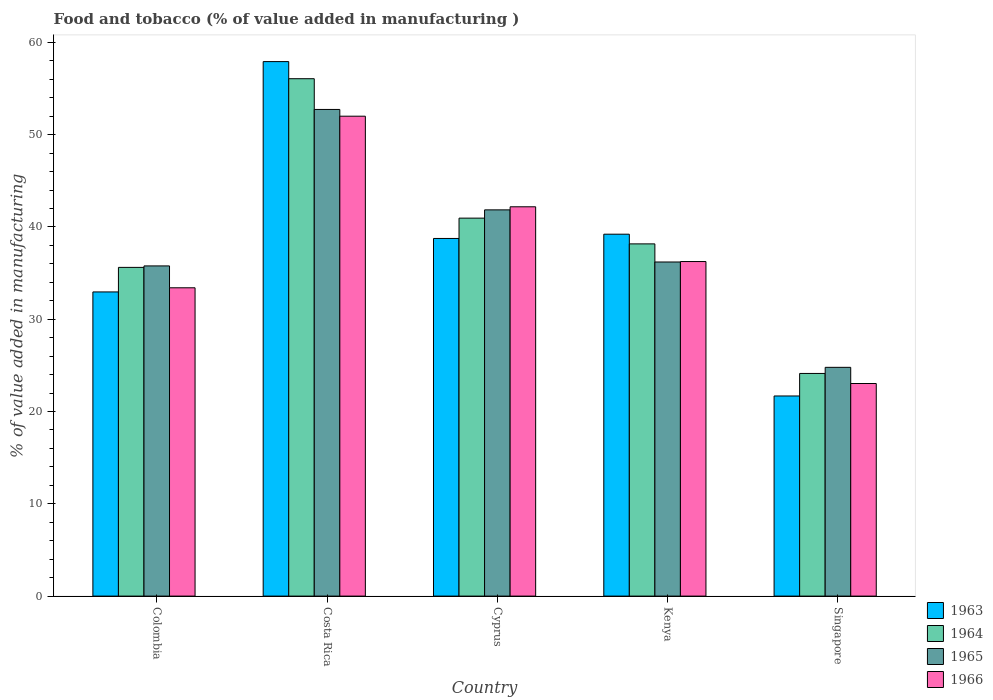Are the number of bars per tick equal to the number of legend labels?
Ensure brevity in your answer.  Yes. What is the label of the 1st group of bars from the left?
Your response must be concise. Colombia. In how many cases, is the number of bars for a given country not equal to the number of legend labels?
Provide a succinct answer. 0. What is the value added in manufacturing food and tobacco in 1964 in Kenya?
Offer a terse response. 38.17. Across all countries, what is the maximum value added in manufacturing food and tobacco in 1966?
Provide a succinct answer. 52. Across all countries, what is the minimum value added in manufacturing food and tobacco in 1965?
Keep it short and to the point. 24.79. In which country was the value added in manufacturing food and tobacco in 1966 maximum?
Provide a short and direct response. Costa Rica. In which country was the value added in manufacturing food and tobacco in 1965 minimum?
Offer a terse response. Singapore. What is the total value added in manufacturing food and tobacco in 1966 in the graph?
Give a very brief answer. 186.89. What is the difference between the value added in manufacturing food and tobacco in 1964 in Colombia and that in Costa Rica?
Provide a short and direct response. -20.45. What is the difference between the value added in manufacturing food and tobacco in 1964 in Kenya and the value added in manufacturing food and tobacco in 1965 in Colombia?
Provide a succinct answer. 2.39. What is the average value added in manufacturing food and tobacco in 1964 per country?
Offer a terse response. 38.99. What is the difference between the value added in manufacturing food and tobacco of/in 1964 and value added in manufacturing food and tobacco of/in 1963 in Kenya?
Your answer should be compact. -1.05. In how many countries, is the value added in manufacturing food and tobacco in 1966 greater than 42 %?
Give a very brief answer. 2. What is the ratio of the value added in manufacturing food and tobacco in 1965 in Cyprus to that in Singapore?
Provide a succinct answer. 1.69. Is the difference between the value added in manufacturing food and tobacco in 1964 in Colombia and Costa Rica greater than the difference between the value added in manufacturing food and tobacco in 1963 in Colombia and Costa Rica?
Provide a short and direct response. Yes. What is the difference between the highest and the second highest value added in manufacturing food and tobacco in 1966?
Keep it short and to the point. -9.82. What is the difference between the highest and the lowest value added in manufacturing food and tobacco in 1964?
Provide a short and direct response. 31.94. Is the sum of the value added in manufacturing food and tobacco in 1964 in Cyprus and Kenya greater than the maximum value added in manufacturing food and tobacco in 1963 across all countries?
Your response must be concise. Yes. What does the 4th bar from the left in Costa Rica represents?
Offer a terse response. 1966. What does the 1st bar from the right in Kenya represents?
Keep it short and to the point. 1966. Is it the case that in every country, the sum of the value added in manufacturing food and tobacco in 1965 and value added in manufacturing food and tobacco in 1964 is greater than the value added in manufacturing food and tobacco in 1966?
Offer a very short reply. Yes. How many countries are there in the graph?
Your answer should be very brief. 5. What is the difference between two consecutive major ticks on the Y-axis?
Keep it short and to the point. 10. Are the values on the major ticks of Y-axis written in scientific E-notation?
Offer a terse response. No. Does the graph contain any zero values?
Make the answer very short. No. What is the title of the graph?
Make the answer very short. Food and tobacco (% of value added in manufacturing ). Does "1960" appear as one of the legend labels in the graph?
Provide a succinct answer. No. What is the label or title of the X-axis?
Ensure brevity in your answer.  Country. What is the label or title of the Y-axis?
Ensure brevity in your answer.  % of value added in manufacturing. What is the % of value added in manufacturing of 1963 in Colombia?
Your answer should be very brief. 32.96. What is the % of value added in manufacturing of 1964 in Colombia?
Provide a succinct answer. 35.62. What is the % of value added in manufacturing of 1965 in Colombia?
Your answer should be compact. 35.78. What is the % of value added in manufacturing in 1966 in Colombia?
Ensure brevity in your answer.  33.41. What is the % of value added in manufacturing of 1963 in Costa Rica?
Keep it short and to the point. 57.92. What is the % of value added in manufacturing of 1964 in Costa Rica?
Keep it short and to the point. 56.07. What is the % of value added in manufacturing in 1965 in Costa Rica?
Keep it short and to the point. 52.73. What is the % of value added in manufacturing of 1966 in Costa Rica?
Provide a succinct answer. 52. What is the % of value added in manufacturing in 1963 in Cyprus?
Make the answer very short. 38.75. What is the % of value added in manufacturing in 1964 in Cyprus?
Ensure brevity in your answer.  40.96. What is the % of value added in manufacturing in 1965 in Cyprus?
Offer a terse response. 41.85. What is the % of value added in manufacturing of 1966 in Cyprus?
Provide a short and direct response. 42.19. What is the % of value added in manufacturing of 1963 in Kenya?
Your response must be concise. 39.22. What is the % of value added in manufacturing in 1964 in Kenya?
Give a very brief answer. 38.17. What is the % of value added in manufacturing in 1965 in Kenya?
Provide a short and direct response. 36.2. What is the % of value added in manufacturing of 1966 in Kenya?
Provide a short and direct response. 36.25. What is the % of value added in manufacturing of 1963 in Singapore?
Keep it short and to the point. 21.69. What is the % of value added in manufacturing of 1964 in Singapore?
Keep it short and to the point. 24.13. What is the % of value added in manufacturing in 1965 in Singapore?
Your answer should be compact. 24.79. What is the % of value added in manufacturing in 1966 in Singapore?
Your answer should be very brief. 23.04. Across all countries, what is the maximum % of value added in manufacturing in 1963?
Offer a very short reply. 57.92. Across all countries, what is the maximum % of value added in manufacturing in 1964?
Provide a succinct answer. 56.07. Across all countries, what is the maximum % of value added in manufacturing of 1965?
Your answer should be very brief. 52.73. Across all countries, what is the maximum % of value added in manufacturing in 1966?
Offer a very short reply. 52. Across all countries, what is the minimum % of value added in manufacturing of 1963?
Your answer should be compact. 21.69. Across all countries, what is the minimum % of value added in manufacturing in 1964?
Offer a terse response. 24.13. Across all countries, what is the minimum % of value added in manufacturing of 1965?
Offer a terse response. 24.79. Across all countries, what is the minimum % of value added in manufacturing of 1966?
Give a very brief answer. 23.04. What is the total % of value added in manufacturing in 1963 in the graph?
Provide a short and direct response. 190.54. What is the total % of value added in manufacturing in 1964 in the graph?
Ensure brevity in your answer.  194.94. What is the total % of value added in manufacturing in 1965 in the graph?
Offer a terse response. 191.36. What is the total % of value added in manufacturing in 1966 in the graph?
Ensure brevity in your answer.  186.89. What is the difference between the % of value added in manufacturing in 1963 in Colombia and that in Costa Rica?
Keep it short and to the point. -24.96. What is the difference between the % of value added in manufacturing of 1964 in Colombia and that in Costa Rica?
Give a very brief answer. -20.45. What is the difference between the % of value added in manufacturing of 1965 in Colombia and that in Costa Rica?
Provide a short and direct response. -16.95. What is the difference between the % of value added in manufacturing in 1966 in Colombia and that in Costa Rica?
Offer a very short reply. -18.59. What is the difference between the % of value added in manufacturing in 1963 in Colombia and that in Cyprus?
Offer a very short reply. -5.79. What is the difference between the % of value added in manufacturing in 1964 in Colombia and that in Cyprus?
Provide a succinct answer. -5.34. What is the difference between the % of value added in manufacturing in 1965 in Colombia and that in Cyprus?
Offer a terse response. -6.07. What is the difference between the % of value added in manufacturing of 1966 in Colombia and that in Cyprus?
Your answer should be very brief. -8.78. What is the difference between the % of value added in manufacturing of 1963 in Colombia and that in Kenya?
Ensure brevity in your answer.  -6.26. What is the difference between the % of value added in manufacturing of 1964 in Colombia and that in Kenya?
Provide a short and direct response. -2.55. What is the difference between the % of value added in manufacturing of 1965 in Colombia and that in Kenya?
Your answer should be compact. -0.42. What is the difference between the % of value added in manufacturing of 1966 in Colombia and that in Kenya?
Your response must be concise. -2.84. What is the difference between the % of value added in manufacturing in 1963 in Colombia and that in Singapore?
Offer a terse response. 11.27. What is the difference between the % of value added in manufacturing in 1964 in Colombia and that in Singapore?
Your answer should be compact. 11.49. What is the difference between the % of value added in manufacturing in 1965 in Colombia and that in Singapore?
Give a very brief answer. 10.99. What is the difference between the % of value added in manufacturing of 1966 in Colombia and that in Singapore?
Offer a very short reply. 10.37. What is the difference between the % of value added in manufacturing in 1963 in Costa Rica and that in Cyprus?
Make the answer very short. 19.17. What is the difference between the % of value added in manufacturing of 1964 in Costa Rica and that in Cyprus?
Make the answer very short. 15.11. What is the difference between the % of value added in manufacturing in 1965 in Costa Rica and that in Cyprus?
Your answer should be compact. 10.88. What is the difference between the % of value added in manufacturing in 1966 in Costa Rica and that in Cyprus?
Ensure brevity in your answer.  9.82. What is the difference between the % of value added in manufacturing of 1963 in Costa Rica and that in Kenya?
Offer a very short reply. 18.7. What is the difference between the % of value added in manufacturing of 1964 in Costa Rica and that in Kenya?
Make the answer very short. 17.9. What is the difference between the % of value added in manufacturing of 1965 in Costa Rica and that in Kenya?
Provide a succinct answer. 16.53. What is the difference between the % of value added in manufacturing of 1966 in Costa Rica and that in Kenya?
Give a very brief answer. 15.75. What is the difference between the % of value added in manufacturing of 1963 in Costa Rica and that in Singapore?
Offer a terse response. 36.23. What is the difference between the % of value added in manufacturing of 1964 in Costa Rica and that in Singapore?
Your response must be concise. 31.94. What is the difference between the % of value added in manufacturing of 1965 in Costa Rica and that in Singapore?
Keep it short and to the point. 27.94. What is the difference between the % of value added in manufacturing of 1966 in Costa Rica and that in Singapore?
Provide a short and direct response. 28.97. What is the difference between the % of value added in manufacturing of 1963 in Cyprus and that in Kenya?
Make the answer very short. -0.46. What is the difference between the % of value added in manufacturing in 1964 in Cyprus and that in Kenya?
Your response must be concise. 2.79. What is the difference between the % of value added in manufacturing of 1965 in Cyprus and that in Kenya?
Offer a terse response. 5.65. What is the difference between the % of value added in manufacturing in 1966 in Cyprus and that in Kenya?
Provide a succinct answer. 5.93. What is the difference between the % of value added in manufacturing in 1963 in Cyprus and that in Singapore?
Provide a succinct answer. 17.07. What is the difference between the % of value added in manufacturing of 1964 in Cyprus and that in Singapore?
Give a very brief answer. 16.83. What is the difference between the % of value added in manufacturing in 1965 in Cyprus and that in Singapore?
Make the answer very short. 17.06. What is the difference between the % of value added in manufacturing of 1966 in Cyprus and that in Singapore?
Keep it short and to the point. 19.15. What is the difference between the % of value added in manufacturing in 1963 in Kenya and that in Singapore?
Make the answer very short. 17.53. What is the difference between the % of value added in manufacturing in 1964 in Kenya and that in Singapore?
Keep it short and to the point. 14.04. What is the difference between the % of value added in manufacturing in 1965 in Kenya and that in Singapore?
Make the answer very short. 11.41. What is the difference between the % of value added in manufacturing in 1966 in Kenya and that in Singapore?
Make the answer very short. 13.22. What is the difference between the % of value added in manufacturing of 1963 in Colombia and the % of value added in manufacturing of 1964 in Costa Rica?
Provide a succinct answer. -23.11. What is the difference between the % of value added in manufacturing of 1963 in Colombia and the % of value added in manufacturing of 1965 in Costa Rica?
Your answer should be compact. -19.77. What is the difference between the % of value added in manufacturing of 1963 in Colombia and the % of value added in manufacturing of 1966 in Costa Rica?
Offer a very short reply. -19.04. What is the difference between the % of value added in manufacturing of 1964 in Colombia and the % of value added in manufacturing of 1965 in Costa Rica?
Offer a very short reply. -17.11. What is the difference between the % of value added in manufacturing in 1964 in Colombia and the % of value added in manufacturing in 1966 in Costa Rica?
Keep it short and to the point. -16.38. What is the difference between the % of value added in manufacturing in 1965 in Colombia and the % of value added in manufacturing in 1966 in Costa Rica?
Make the answer very short. -16.22. What is the difference between the % of value added in manufacturing in 1963 in Colombia and the % of value added in manufacturing in 1964 in Cyprus?
Ensure brevity in your answer.  -8. What is the difference between the % of value added in manufacturing of 1963 in Colombia and the % of value added in manufacturing of 1965 in Cyprus?
Your answer should be very brief. -8.89. What is the difference between the % of value added in manufacturing of 1963 in Colombia and the % of value added in manufacturing of 1966 in Cyprus?
Offer a terse response. -9.23. What is the difference between the % of value added in manufacturing of 1964 in Colombia and the % of value added in manufacturing of 1965 in Cyprus?
Offer a terse response. -6.23. What is the difference between the % of value added in manufacturing of 1964 in Colombia and the % of value added in manufacturing of 1966 in Cyprus?
Offer a terse response. -6.57. What is the difference between the % of value added in manufacturing in 1965 in Colombia and the % of value added in manufacturing in 1966 in Cyprus?
Your response must be concise. -6.41. What is the difference between the % of value added in manufacturing in 1963 in Colombia and the % of value added in manufacturing in 1964 in Kenya?
Give a very brief answer. -5.21. What is the difference between the % of value added in manufacturing in 1963 in Colombia and the % of value added in manufacturing in 1965 in Kenya?
Make the answer very short. -3.24. What is the difference between the % of value added in manufacturing of 1963 in Colombia and the % of value added in manufacturing of 1966 in Kenya?
Ensure brevity in your answer.  -3.29. What is the difference between the % of value added in manufacturing of 1964 in Colombia and the % of value added in manufacturing of 1965 in Kenya?
Give a very brief answer. -0.58. What is the difference between the % of value added in manufacturing in 1964 in Colombia and the % of value added in manufacturing in 1966 in Kenya?
Provide a short and direct response. -0.63. What is the difference between the % of value added in manufacturing in 1965 in Colombia and the % of value added in manufacturing in 1966 in Kenya?
Provide a succinct answer. -0.47. What is the difference between the % of value added in manufacturing in 1963 in Colombia and the % of value added in manufacturing in 1964 in Singapore?
Your answer should be compact. 8.83. What is the difference between the % of value added in manufacturing in 1963 in Colombia and the % of value added in manufacturing in 1965 in Singapore?
Your answer should be compact. 8.17. What is the difference between the % of value added in manufacturing of 1963 in Colombia and the % of value added in manufacturing of 1966 in Singapore?
Your answer should be compact. 9.92. What is the difference between the % of value added in manufacturing of 1964 in Colombia and the % of value added in manufacturing of 1965 in Singapore?
Keep it short and to the point. 10.83. What is the difference between the % of value added in manufacturing in 1964 in Colombia and the % of value added in manufacturing in 1966 in Singapore?
Offer a terse response. 12.58. What is the difference between the % of value added in manufacturing of 1965 in Colombia and the % of value added in manufacturing of 1966 in Singapore?
Offer a terse response. 12.74. What is the difference between the % of value added in manufacturing in 1963 in Costa Rica and the % of value added in manufacturing in 1964 in Cyprus?
Ensure brevity in your answer.  16.96. What is the difference between the % of value added in manufacturing in 1963 in Costa Rica and the % of value added in manufacturing in 1965 in Cyprus?
Your answer should be compact. 16.07. What is the difference between the % of value added in manufacturing in 1963 in Costa Rica and the % of value added in manufacturing in 1966 in Cyprus?
Offer a very short reply. 15.73. What is the difference between the % of value added in manufacturing in 1964 in Costa Rica and the % of value added in manufacturing in 1965 in Cyprus?
Provide a succinct answer. 14.21. What is the difference between the % of value added in manufacturing in 1964 in Costa Rica and the % of value added in manufacturing in 1966 in Cyprus?
Offer a terse response. 13.88. What is the difference between the % of value added in manufacturing of 1965 in Costa Rica and the % of value added in manufacturing of 1966 in Cyprus?
Offer a very short reply. 10.55. What is the difference between the % of value added in manufacturing in 1963 in Costa Rica and the % of value added in manufacturing in 1964 in Kenya?
Your answer should be very brief. 19.75. What is the difference between the % of value added in manufacturing in 1963 in Costa Rica and the % of value added in manufacturing in 1965 in Kenya?
Your answer should be very brief. 21.72. What is the difference between the % of value added in manufacturing of 1963 in Costa Rica and the % of value added in manufacturing of 1966 in Kenya?
Offer a very short reply. 21.67. What is the difference between the % of value added in manufacturing of 1964 in Costa Rica and the % of value added in manufacturing of 1965 in Kenya?
Your response must be concise. 19.86. What is the difference between the % of value added in manufacturing in 1964 in Costa Rica and the % of value added in manufacturing in 1966 in Kenya?
Keep it short and to the point. 19.81. What is the difference between the % of value added in manufacturing in 1965 in Costa Rica and the % of value added in manufacturing in 1966 in Kenya?
Make the answer very short. 16.48. What is the difference between the % of value added in manufacturing in 1963 in Costa Rica and the % of value added in manufacturing in 1964 in Singapore?
Offer a terse response. 33.79. What is the difference between the % of value added in manufacturing of 1963 in Costa Rica and the % of value added in manufacturing of 1965 in Singapore?
Ensure brevity in your answer.  33.13. What is the difference between the % of value added in manufacturing in 1963 in Costa Rica and the % of value added in manufacturing in 1966 in Singapore?
Offer a terse response. 34.88. What is the difference between the % of value added in manufacturing of 1964 in Costa Rica and the % of value added in manufacturing of 1965 in Singapore?
Offer a terse response. 31.28. What is the difference between the % of value added in manufacturing in 1964 in Costa Rica and the % of value added in manufacturing in 1966 in Singapore?
Provide a succinct answer. 33.03. What is the difference between the % of value added in manufacturing in 1965 in Costa Rica and the % of value added in manufacturing in 1966 in Singapore?
Give a very brief answer. 29.7. What is the difference between the % of value added in manufacturing in 1963 in Cyprus and the % of value added in manufacturing in 1964 in Kenya?
Give a very brief answer. 0.59. What is the difference between the % of value added in manufacturing of 1963 in Cyprus and the % of value added in manufacturing of 1965 in Kenya?
Give a very brief answer. 2.55. What is the difference between the % of value added in manufacturing in 1963 in Cyprus and the % of value added in manufacturing in 1966 in Kenya?
Ensure brevity in your answer.  2.5. What is the difference between the % of value added in manufacturing of 1964 in Cyprus and the % of value added in manufacturing of 1965 in Kenya?
Make the answer very short. 4.75. What is the difference between the % of value added in manufacturing in 1964 in Cyprus and the % of value added in manufacturing in 1966 in Kenya?
Your response must be concise. 4.7. What is the difference between the % of value added in manufacturing of 1965 in Cyprus and the % of value added in manufacturing of 1966 in Kenya?
Offer a very short reply. 5.6. What is the difference between the % of value added in manufacturing of 1963 in Cyprus and the % of value added in manufacturing of 1964 in Singapore?
Offer a very short reply. 14.63. What is the difference between the % of value added in manufacturing of 1963 in Cyprus and the % of value added in manufacturing of 1965 in Singapore?
Your answer should be compact. 13.96. What is the difference between the % of value added in manufacturing of 1963 in Cyprus and the % of value added in manufacturing of 1966 in Singapore?
Your response must be concise. 15.72. What is the difference between the % of value added in manufacturing in 1964 in Cyprus and the % of value added in manufacturing in 1965 in Singapore?
Your response must be concise. 16.17. What is the difference between the % of value added in manufacturing of 1964 in Cyprus and the % of value added in manufacturing of 1966 in Singapore?
Provide a succinct answer. 17.92. What is the difference between the % of value added in manufacturing in 1965 in Cyprus and the % of value added in manufacturing in 1966 in Singapore?
Your response must be concise. 18.82. What is the difference between the % of value added in manufacturing of 1963 in Kenya and the % of value added in manufacturing of 1964 in Singapore?
Your answer should be compact. 15.09. What is the difference between the % of value added in manufacturing of 1963 in Kenya and the % of value added in manufacturing of 1965 in Singapore?
Your answer should be compact. 14.43. What is the difference between the % of value added in manufacturing of 1963 in Kenya and the % of value added in manufacturing of 1966 in Singapore?
Your answer should be compact. 16.18. What is the difference between the % of value added in manufacturing in 1964 in Kenya and the % of value added in manufacturing in 1965 in Singapore?
Provide a succinct answer. 13.38. What is the difference between the % of value added in manufacturing of 1964 in Kenya and the % of value added in manufacturing of 1966 in Singapore?
Your answer should be compact. 15.13. What is the difference between the % of value added in manufacturing of 1965 in Kenya and the % of value added in manufacturing of 1966 in Singapore?
Provide a short and direct response. 13.17. What is the average % of value added in manufacturing in 1963 per country?
Give a very brief answer. 38.11. What is the average % of value added in manufacturing in 1964 per country?
Provide a short and direct response. 38.99. What is the average % of value added in manufacturing in 1965 per country?
Your answer should be compact. 38.27. What is the average % of value added in manufacturing in 1966 per country?
Provide a succinct answer. 37.38. What is the difference between the % of value added in manufacturing of 1963 and % of value added in manufacturing of 1964 in Colombia?
Give a very brief answer. -2.66. What is the difference between the % of value added in manufacturing in 1963 and % of value added in manufacturing in 1965 in Colombia?
Make the answer very short. -2.82. What is the difference between the % of value added in manufacturing in 1963 and % of value added in manufacturing in 1966 in Colombia?
Offer a very short reply. -0.45. What is the difference between the % of value added in manufacturing in 1964 and % of value added in manufacturing in 1965 in Colombia?
Provide a short and direct response. -0.16. What is the difference between the % of value added in manufacturing in 1964 and % of value added in manufacturing in 1966 in Colombia?
Make the answer very short. 2.21. What is the difference between the % of value added in manufacturing of 1965 and % of value added in manufacturing of 1966 in Colombia?
Give a very brief answer. 2.37. What is the difference between the % of value added in manufacturing in 1963 and % of value added in manufacturing in 1964 in Costa Rica?
Your answer should be very brief. 1.85. What is the difference between the % of value added in manufacturing of 1963 and % of value added in manufacturing of 1965 in Costa Rica?
Offer a terse response. 5.19. What is the difference between the % of value added in manufacturing in 1963 and % of value added in manufacturing in 1966 in Costa Rica?
Make the answer very short. 5.92. What is the difference between the % of value added in manufacturing in 1964 and % of value added in manufacturing in 1965 in Costa Rica?
Offer a terse response. 3.33. What is the difference between the % of value added in manufacturing of 1964 and % of value added in manufacturing of 1966 in Costa Rica?
Ensure brevity in your answer.  4.06. What is the difference between the % of value added in manufacturing of 1965 and % of value added in manufacturing of 1966 in Costa Rica?
Your answer should be compact. 0.73. What is the difference between the % of value added in manufacturing of 1963 and % of value added in manufacturing of 1964 in Cyprus?
Give a very brief answer. -2.2. What is the difference between the % of value added in manufacturing of 1963 and % of value added in manufacturing of 1965 in Cyprus?
Give a very brief answer. -3.1. What is the difference between the % of value added in manufacturing of 1963 and % of value added in manufacturing of 1966 in Cyprus?
Offer a terse response. -3.43. What is the difference between the % of value added in manufacturing of 1964 and % of value added in manufacturing of 1965 in Cyprus?
Provide a succinct answer. -0.9. What is the difference between the % of value added in manufacturing in 1964 and % of value added in manufacturing in 1966 in Cyprus?
Keep it short and to the point. -1.23. What is the difference between the % of value added in manufacturing of 1965 and % of value added in manufacturing of 1966 in Cyprus?
Your answer should be compact. -0.33. What is the difference between the % of value added in manufacturing in 1963 and % of value added in manufacturing in 1964 in Kenya?
Offer a very short reply. 1.05. What is the difference between the % of value added in manufacturing in 1963 and % of value added in manufacturing in 1965 in Kenya?
Make the answer very short. 3.01. What is the difference between the % of value added in manufacturing of 1963 and % of value added in manufacturing of 1966 in Kenya?
Provide a succinct answer. 2.96. What is the difference between the % of value added in manufacturing of 1964 and % of value added in manufacturing of 1965 in Kenya?
Your response must be concise. 1.96. What is the difference between the % of value added in manufacturing of 1964 and % of value added in manufacturing of 1966 in Kenya?
Make the answer very short. 1.91. What is the difference between the % of value added in manufacturing in 1965 and % of value added in manufacturing in 1966 in Kenya?
Provide a succinct answer. -0.05. What is the difference between the % of value added in manufacturing of 1963 and % of value added in manufacturing of 1964 in Singapore?
Your answer should be compact. -2.44. What is the difference between the % of value added in manufacturing of 1963 and % of value added in manufacturing of 1965 in Singapore?
Offer a terse response. -3.1. What is the difference between the % of value added in manufacturing of 1963 and % of value added in manufacturing of 1966 in Singapore?
Offer a very short reply. -1.35. What is the difference between the % of value added in manufacturing in 1964 and % of value added in manufacturing in 1965 in Singapore?
Give a very brief answer. -0.66. What is the difference between the % of value added in manufacturing of 1964 and % of value added in manufacturing of 1966 in Singapore?
Offer a terse response. 1.09. What is the difference between the % of value added in manufacturing of 1965 and % of value added in manufacturing of 1966 in Singapore?
Offer a very short reply. 1.75. What is the ratio of the % of value added in manufacturing in 1963 in Colombia to that in Costa Rica?
Provide a succinct answer. 0.57. What is the ratio of the % of value added in manufacturing in 1964 in Colombia to that in Costa Rica?
Your answer should be compact. 0.64. What is the ratio of the % of value added in manufacturing of 1965 in Colombia to that in Costa Rica?
Provide a succinct answer. 0.68. What is the ratio of the % of value added in manufacturing of 1966 in Colombia to that in Costa Rica?
Ensure brevity in your answer.  0.64. What is the ratio of the % of value added in manufacturing in 1963 in Colombia to that in Cyprus?
Your answer should be very brief. 0.85. What is the ratio of the % of value added in manufacturing in 1964 in Colombia to that in Cyprus?
Your response must be concise. 0.87. What is the ratio of the % of value added in manufacturing of 1965 in Colombia to that in Cyprus?
Your answer should be very brief. 0.85. What is the ratio of the % of value added in manufacturing of 1966 in Colombia to that in Cyprus?
Your response must be concise. 0.79. What is the ratio of the % of value added in manufacturing of 1963 in Colombia to that in Kenya?
Provide a short and direct response. 0.84. What is the ratio of the % of value added in manufacturing of 1964 in Colombia to that in Kenya?
Provide a succinct answer. 0.93. What is the ratio of the % of value added in manufacturing in 1965 in Colombia to that in Kenya?
Keep it short and to the point. 0.99. What is the ratio of the % of value added in manufacturing of 1966 in Colombia to that in Kenya?
Your answer should be very brief. 0.92. What is the ratio of the % of value added in manufacturing of 1963 in Colombia to that in Singapore?
Provide a succinct answer. 1.52. What is the ratio of the % of value added in manufacturing of 1964 in Colombia to that in Singapore?
Give a very brief answer. 1.48. What is the ratio of the % of value added in manufacturing of 1965 in Colombia to that in Singapore?
Provide a succinct answer. 1.44. What is the ratio of the % of value added in manufacturing in 1966 in Colombia to that in Singapore?
Give a very brief answer. 1.45. What is the ratio of the % of value added in manufacturing of 1963 in Costa Rica to that in Cyprus?
Give a very brief answer. 1.49. What is the ratio of the % of value added in manufacturing in 1964 in Costa Rica to that in Cyprus?
Your answer should be compact. 1.37. What is the ratio of the % of value added in manufacturing in 1965 in Costa Rica to that in Cyprus?
Offer a terse response. 1.26. What is the ratio of the % of value added in manufacturing in 1966 in Costa Rica to that in Cyprus?
Provide a succinct answer. 1.23. What is the ratio of the % of value added in manufacturing of 1963 in Costa Rica to that in Kenya?
Keep it short and to the point. 1.48. What is the ratio of the % of value added in manufacturing in 1964 in Costa Rica to that in Kenya?
Your response must be concise. 1.47. What is the ratio of the % of value added in manufacturing in 1965 in Costa Rica to that in Kenya?
Your answer should be compact. 1.46. What is the ratio of the % of value added in manufacturing of 1966 in Costa Rica to that in Kenya?
Ensure brevity in your answer.  1.43. What is the ratio of the % of value added in manufacturing in 1963 in Costa Rica to that in Singapore?
Your response must be concise. 2.67. What is the ratio of the % of value added in manufacturing of 1964 in Costa Rica to that in Singapore?
Your answer should be very brief. 2.32. What is the ratio of the % of value added in manufacturing of 1965 in Costa Rica to that in Singapore?
Your answer should be compact. 2.13. What is the ratio of the % of value added in manufacturing of 1966 in Costa Rica to that in Singapore?
Offer a terse response. 2.26. What is the ratio of the % of value added in manufacturing of 1963 in Cyprus to that in Kenya?
Your response must be concise. 0.99. What is the ratio of the % of value added in manufacturing of 1964 in Cyprus to that in Kenya?
Your response must be concise. 1.07. What is the ratio of the % of value added in manufacturing in 1965 in Cyprus to that in Kenya?
Provide a succinct answer. 1.16. What is the ratio of the % of value added in manufacturing of 1966 in Cyprus to that in Kenya?
Make the answer very short. 1.16. What is the ratio of the % of value added in manufacturing in 1963 in Cyprus to that in Singapore?
Your response must be concise. 1.79. What is the ratio of the % of value added in manufacturing of 1964 in Cyprus to that in Singapore?
Give a very brief answer. 1.7. What is the ratio of the % of value added in manufacturing of 1965 in Cyprus to that in Singapore?
Make the answer very short. 1.69. What is the ratio of the % of value added in manufacturing of 1966 in Cyprus to that in Singapore?
Offer a very short reply. 1.83. What is the ratio of the % of value added in manufacturing in 1963 in Kenya to that in Singapore?
Provide a succinct answer. 1.81. What is the ratio of the % of value added in manufacturing in 1964 in Kenya to that in Singapore?
Make the answer very short. 1.58. What is the ratio of the % of value added in manufacturing of 1965 in Kenya to that in Singapore?
Keep it short and to the point. 1.46. What is the ratio of the % of value added in manufacturing in 1966 in Kenya to that in Singapore?
Provide a succinct answer. 1.57. What is the difference between the highest and the second highest % of value added in manufacturing of 1963?
Offer a terse response. 18.7. What is the difference between the highest and the second highest % of value added in manufacturing in 1964?
Keep it short and to the point. 15.11. What is the difference between the highest and the second highest % of value added in manufacturing of 1965?
Keep it short and to the point. 10.88. What is the difference between the highest and the second highest % of value added in manufacturing of 1966?
Give a very brief answer. 9.82. What is the difference between the highest and the lowest % of value added in manufacturing in 1963?
Make the answer very short. 36.23. What is the difference between the highest and the lowest % of value added in manufacturing in 1964?
Your response must be concise. 31.94. What is the difference between the highest and the lowest % of value added in manufacturing of 1965?
Offer a terse response. 27.94. What is the difference between the highest and the lowest % of value added in manufacturing of 1966?
Your answer should be very brief. 28.97. 